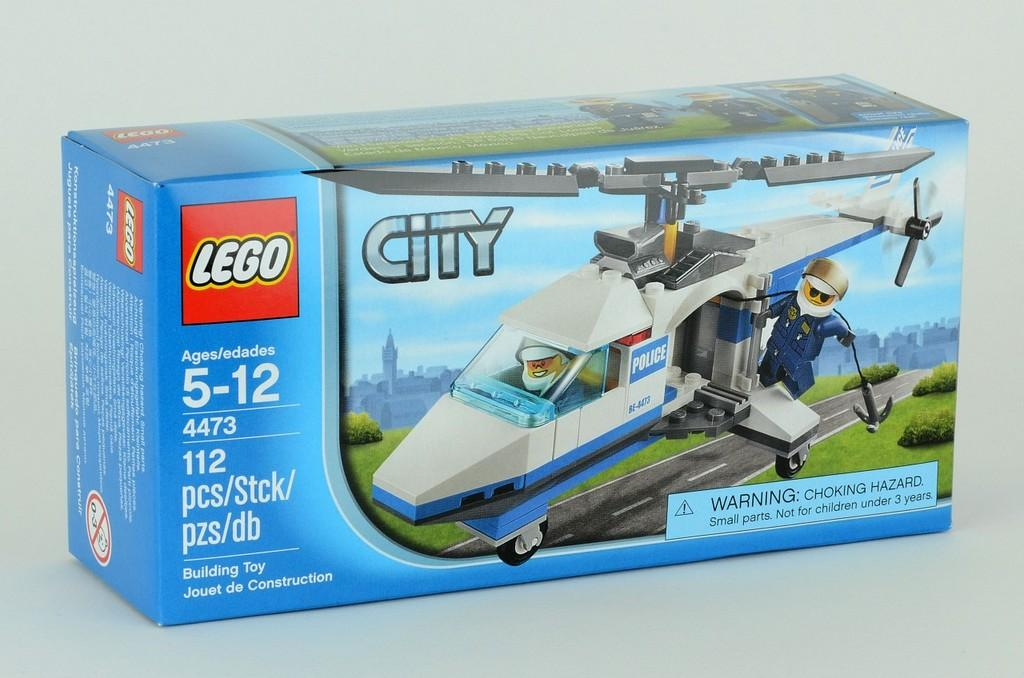Provide a one-sentence caption for the provided image. a box of city legos to build a helicopter for ages 5-12. 